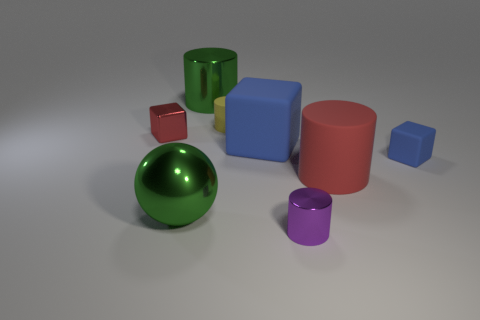Subtract all rubber blocks. How many blocks are left? 1 Subtract all green cylinders. How many cylinders are left? 3 Add 1 blue rubber cubes. How many objects exist? 9 Subtract 3 cylinders. How many cylinders are left? 1 Subtract all spheres. How many objects are left? 7 Subtract all gray cubes. Subtract all blue cylinders. How many cubes are left? 3 Subtract all yellow cylinders. How many red blocks are left? 1 Subtract all purple objects. Subtract all big blue matte cubes. How many objects are left? 6 Add 7 cubes. How many cubes are left? 10 Add 7 red shiny cylinders. How many red shiny cylinders exist? 7 